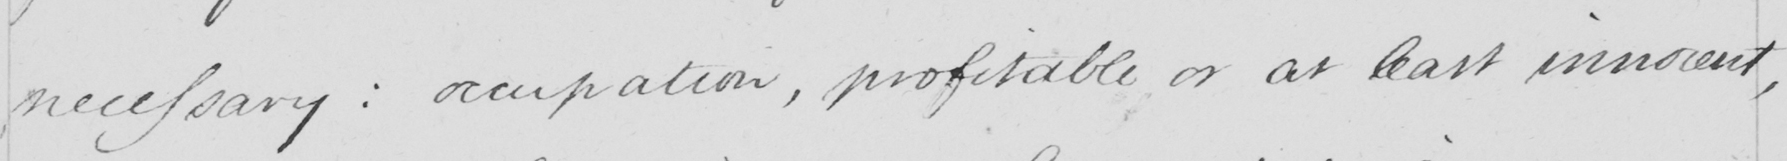Transcribe the text shown in this historical manuscript line. necessary :  occupation , profitable or at least innocent , 